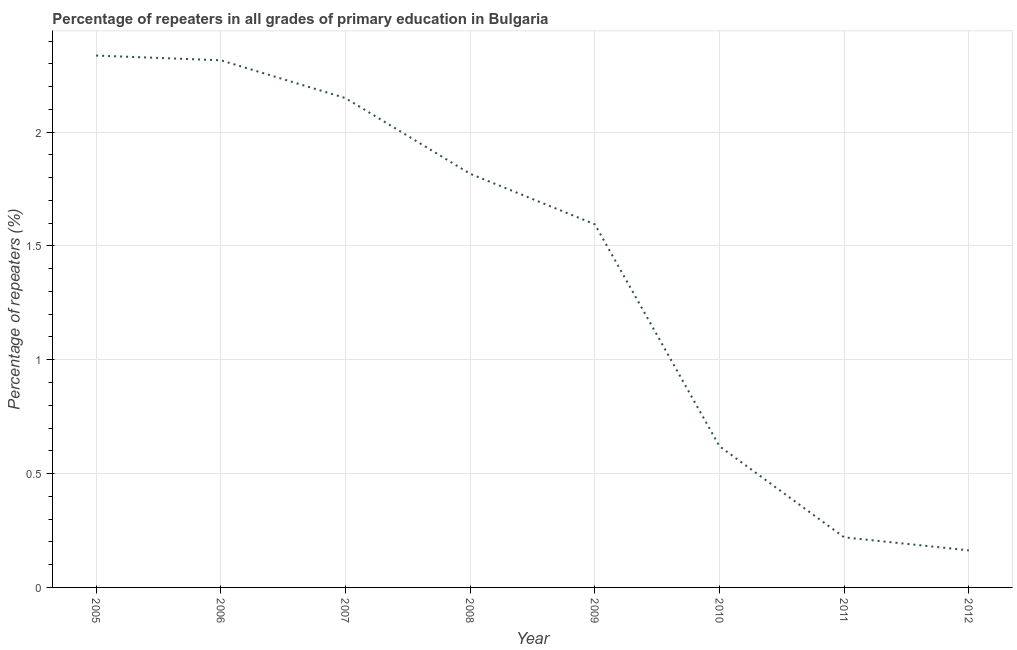What is the percentage of repeaters in primary education in 2012?
Your answer should be very brief. 0.16. Across all years, what is the maximum percentage of repeaters in primary education?
Your answer should be very brief. 2.34. Across all years, what is the minimum percentage of repeaters in primary education?
Offer a terse response. 0.16. In which year was the percentage of repeaters in primary education maximum?
Give a very brief answer. 2005. In which year was the percentage of repeaters in primary education minimum?
Your response must be concise. 2012. What is the sum of the percentage of repeaters in primary education?
Provide a short and direct response. 11.22. What is the difference between the percentage of repeaters in primary education in 2010 and 2012?
Offer a very short reply. 0.46. What is the average percentage of repeaters in primary education per year?
Your answer should be compact. 1.4. What is the median percentage of repeaters in primary education?
Make the answer very short. 1.71. In how many years, is the percentage of repeaters in primary education greater than 1.6 %?
Provide a short and direct response. 4. Do a majority of the years between 2011 and 2005 (inclusive) have percentage of repeaters in primary education greater than 0.2 %?
Provide a succinct answer. Yes. What is the ratio of the percentage of repeaters in primary education in 2008 to that in 2009?
Provide a succinct answer. 1.14. Is the percentage of repeaters in primary education in 2009 less than that in 2012?
Offer a terse response. No. Is the difference between the percentage of repeaters in primary education in 2006 and 2009 greater than the difference between any two years?
Give a very brief answer. No. What is the difference between the highest and the second highest percentage of repeaters in primary education?
Offer a very short reply. 0.02. What is the difference between the highest and the lowest percentage of repeaters in primary education?
Your answer should be compact. 2.17. In how many years, is the percentage of repeaters in primary education greater than the average percentage of repeaters in primary education taken over all years?
Offer a terse response. 5. Does the percentage of repeaters in primary education monotonically increase over the years?
Your answer should be very brief. No. How many lines are there?
Provide a short and direct response. 1. How many years are there in the graph?
Offer a very short reply. 8. Are the values on the major ticks of Y-axis written in scientific E-notation?
Offer a very short reply. No. What is the title of the graph?
Provide a succinct answer. Percentage of repeaters in all grades of primary education in Bulgaria. What is the label or title of the Y-axis?
Your answer should be very brief. Percentage of repeaters (%). What is the Percentage of repeaters (%) of 2005?
Offer a terse response. 2.34. What is the Percentage of repeaters (%) of 2006?
Make the answer very short. 2.32. What is the Percentage of repeaters (%) of 2007?
Provide a succinct answer. 2.15. What is the Percentage of repeaters (%) of 2008?
Keep it short and to the point. 1.82. What is the Percentage of repeaters (%) in 2009?
Give a very brief answer. 1.59. What is the Percentage of repeaters (%) in 2010?
Your answer should be compact. 0.62. What is the Percentage of repeaters (%) in 2011?
Offer a terse response. 0.22. What is the Percentage of repeaters (%) of 2012?
Ensure brevity in your answer.  0.16. What is the difference between the Percentage of repeaters (%) in 2005 and 2006?
Make the answer very short. 0.02. What is the difference between the Percentage of repeaters (%) in 2005 and 2007?
Ensure brevity in your answer.  0.19. What is the difference between the Percentage of repeaters (%) in 2005 and 2008?
Your answer should be compact. 0.52. What is the difference between the Percentage of repeaters (%) in 2005 and 2009?
Your answer should be very brief. 0.74. What is the difference between the Percentage of repeaters (%) in 2005 and 2010?
Keep it short and to the point. 1.72. What is the difference between the Percentage of repeaters (%) in 2005 and 2011?
Provide a succinct answer. 2.12. What is the difference between the Percentage of repeaters (%) in 2005 and 2012?
Make the answer very short. 2.17. What is the difference between the Percentage of repeaters (%) in 2006 and 2007?
Your answer should be compact. 0.17. What is the difference between the Percentage of repeaters (%) in 2006 and 2008?
Provide a succinct answer. 0.5. What is the difference between the Percentage of repeaters (%) in 2006 and 2009?
Offer a terse response. 0.72. What is the difference between the Percentage of repeaters (%) in 2006 and 2010?
Provide a short and direct response. 1.7. What is the difference between the Percentage of repeaters (%) in 2006 and 2011?
Your answer should be compact. 2.1. What is the difference between the Percentage of repeaters (%) in 2006 and 2012?
Ensure brevity in your answer.  2.15. What is the difference between the Percentage of repeaters (%) in 2007 and 2008?
Offer a terse response. 0.33. What is the difference between the Percentage of repeaters (%) in 2007 and 2009?
Your answer should be compact. 0.55. What is the difference between the Percentage of repeaters (%) in 2007 and 2010?
Make the answer very short. 1.53. What is the difference between the Percentage of repeaters (%) in 2007 and 2011?
Make the answer very short. 1.93. What is the difference between the Percentage of repeaters (%) in 2007 and 2012?
Your response must be concise. 1.99. What is the difference between the Percentage of repeaters (%) in 2008 and 2009?
Provide a succinct answer. 0.22. What is the difference between the Percentage of repeaters (%) in 2008 and 2010?
Make the answer very short. 1.2. What is the difference between the Percentage of repeaters (%) in 2008 and 2011?
Offer a terse response. 1.6. What is the difference between the Percentage of repeaters (%) in 2008 and 2012?
Your answer should be very brief. 1.65. What is the difference between the Percentage of repeaters (%) in 2009 and 2010?
Your answer should be compact. 0.98. What is the difference between the Percentage of repeaters (%) in 2009 and 2011?
Provide a succinct answer. 1.38. What is the difference between the Percentage of repeaters (%) in 2009 and 2012?
Keep it short and to the point. 1.43. What is the difference between the Percentage of repeaters (%) in 2010 and 2011?
Make the answer very short. 0.4. What is the difference between the Percentage of repeaters (%) in 2010 and 2012?
Ensure brevity in your answer.  0.46. What is the difference between the Percentage of repeaters (%) in 2011 and 2012?
Provide a succinct answer. 0.06. What is the ratio of the Percentage of repeaters (%) in 2005 to that in 2007?
Offer a very short reply. 1.09. What is the ratio of the Percentage of repeaters (%) in 2005 to that in 2008?
Ensure brevity in your answer.  1.29. What is the ratio of the Percentage of repeaters (%) in 2005 to that in 2009?
Offer a very short reply. 1.47. What is the ratio of the Percentage of repeaters (%) in 2005 to that in 2010?
Your answer should be compact. 3.77. What is the ratio of the Percentage of repeaters (%) in 2005 to that in 2011?
Your answer should be compact. 10.62. What is the ratio of the Percentage of repeaters (%) in 2005 to that in 2012?
Give a very brief answer. 14.35. What is the ratio of the Percentage of repeaters (%) in 2006 to that in 2007?
Your answer should be compact. 1.08. What is the ratio of the Percentage of repeaters (%) in 2006 to that in 2008?
Provide a succinct answer. 1.27. What is the ratio of the Percentage of repeaters (%) in 2006 to that in 2009?
Make the answer very short. 1.45. What is the ratio of the Percentage of repeaters (%) in 2006 to that in 2010?
Give a very brief answer. 3.73. What is the ratio of the Percentage of repeaters (%) in 2006 to that in 2011?
Your answer should be very brief. 10.53. What is the ratio of the Percentage of repeaters (%) in 2006 to that in 2012?
Provide a short and direct response. 14.22. What is the ratio of the Percentage of repeaters (%) in 2007 to that in 2008?
Offer a terse response. 1.18. What is the ratio of the Percentage of repeaters (%) in 2007 to that in 2009?
Provide a short and direct response. 1.35. What is the ratio of the Percentage of repeaters (%) in 2007 to that in 2010?
Provide a short and direct response. 3.47. What is the ratio of the Percentage of repeaters (%) in 2007 to that in 2011?
Offer a terse response. 9.77. What is the ratio of the Percentage of repeaters (%) in 2007 to that in 2012?
Give a very brief answer. 13.2. What is the ratio of the Percentage of repeaters (%) in 2008 to that in 2009?
Offer a very short reply. 1.14. What is the ratio of the Percentage of repeaters (%) in 2008 to that in 2010?
Offer a very short reply. 2.93. What is the ratio of the Percentage of repeaters (%) in 2008 to that in 2011?
Offer a terse response. 8.26. What is the ratio of the Percentage of repeaters (%) in 2008 to that in 2012?
Offer a terse response. 11.16. What is the ratio of the Percentage of repeaters (%) in 2009 to that in 2010?
Ensure brevity in your answer.  2.57. What is the ratio of the Percentage of repeaters (%) in 2009 to that in 2011?
Your response must be concise. 7.25. What is the ratio of the Percentage of repeaters (%) in 2009 to that in 2012?
Offer a terse response. 9.79. What is the ratio of the Percentage of repeaters (%) in 2010 to that in 2011?
Give a very brief answer. 2.82. What is the ratio of the Percentage of repeaters (%) in 2010 to that in 2012?
Ensure brevity in your answer.  3.81. What is the ratio of the Percentage of repeaters (%) in 2011 to that in 2012?
Your answer should be very brief. 1.35. 